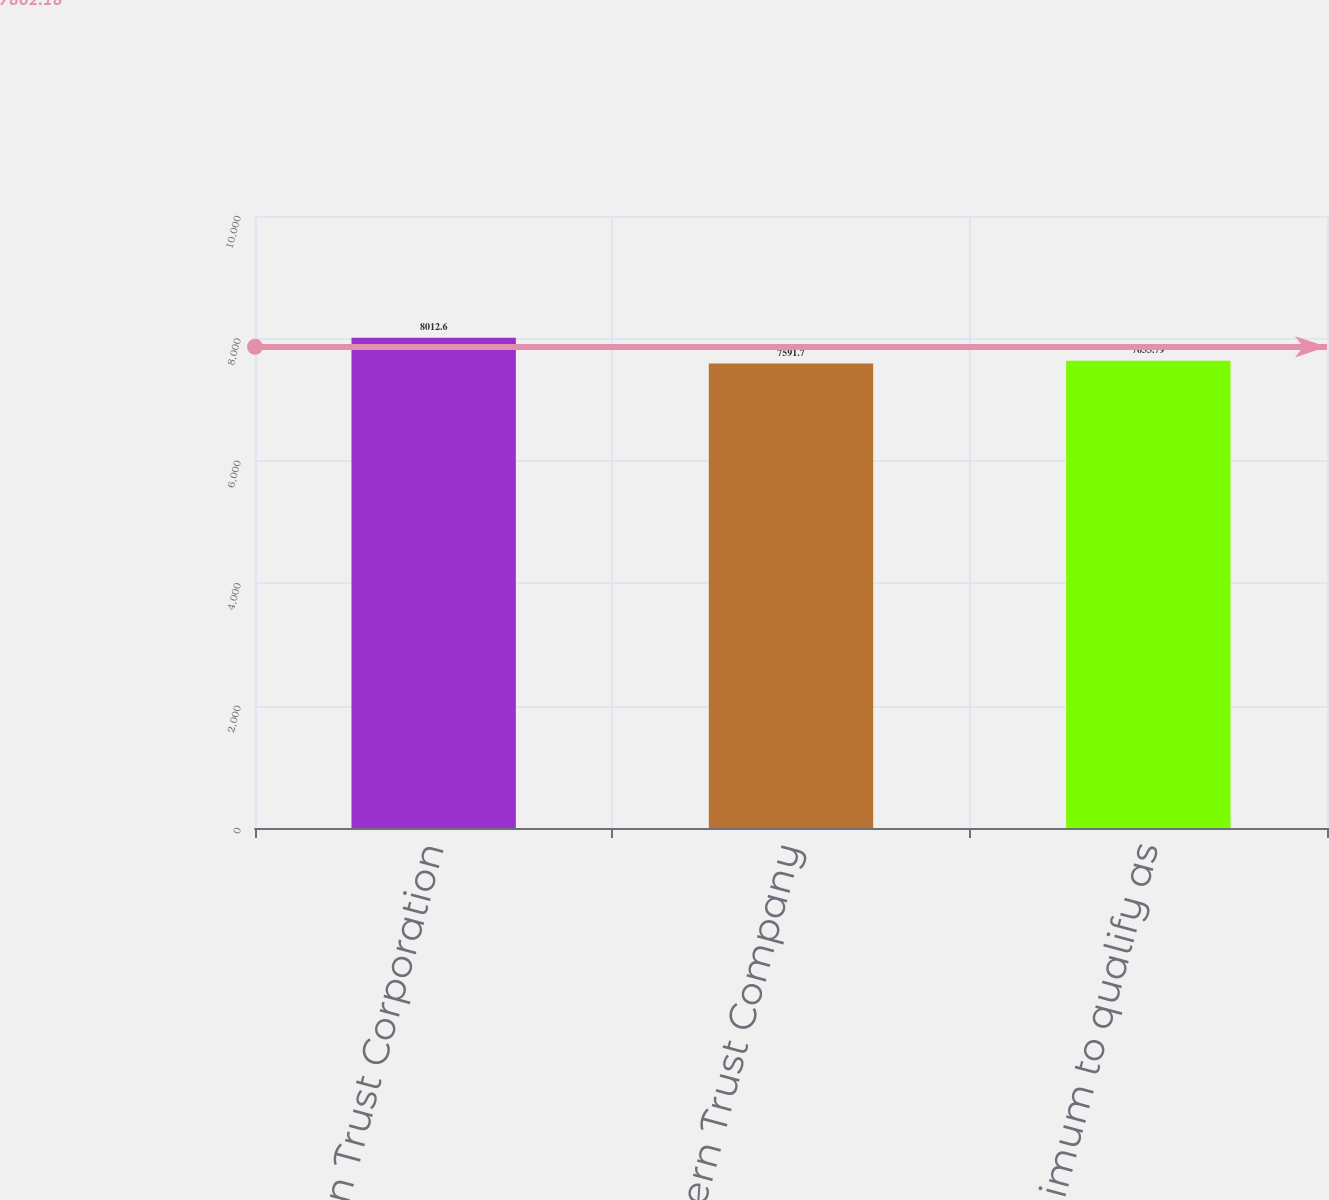Convert chart to OTSL. <chart><loc_0><loc_0><loc_500><loc_500><bar_chart><fcel>Northern Trust Corporation<fcel>The Northern Trust Company<fcel>Minimum to qualify as<nl><fcel>8012.6<fcel>7591.7<fcel>7633.79<nl></chart> 